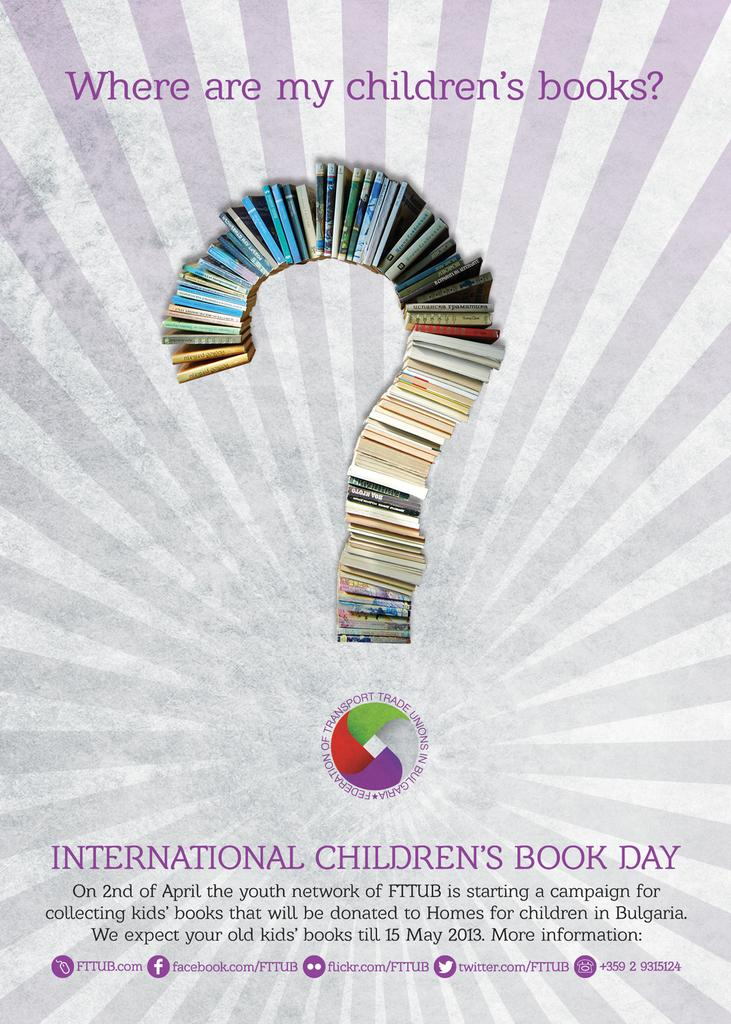<image>
Create a compact narrative representing the image presented. A poster asking "Where are my children's books?" 